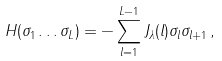Convert formula to latex. <formula><loc_0><loc_0><loc_500><loc_500>H ( \sigma _ { 1 } \dots \sigma _ { L } ) = - \sum _ { l = 1 } ^ { L - 1 } J _ { \lambda } ( l ) \sigma _ { l } \sigma _ { l + 1 } \, ,</formula> 